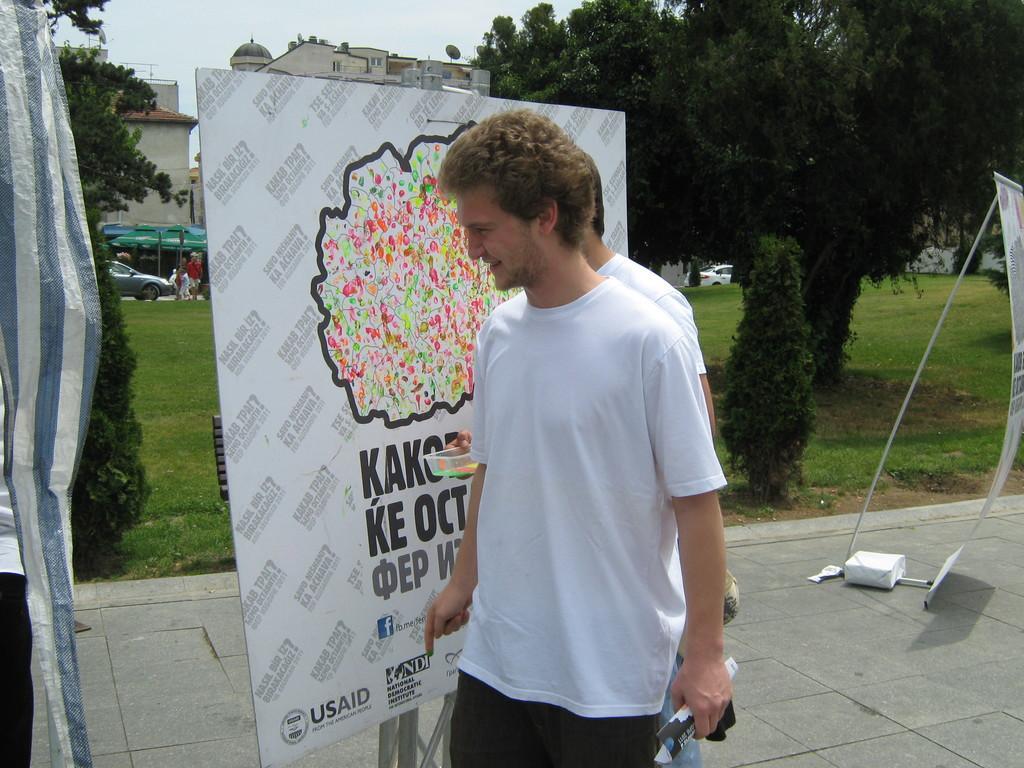Could you give a brief overview of what you see in this image? In this image there are two persons standing on the floor. Beside them there is a board on which there is paint. In the background there are buildings and trees. The man behind the man is holding the box which has paint in it. In the background there is a ground. 